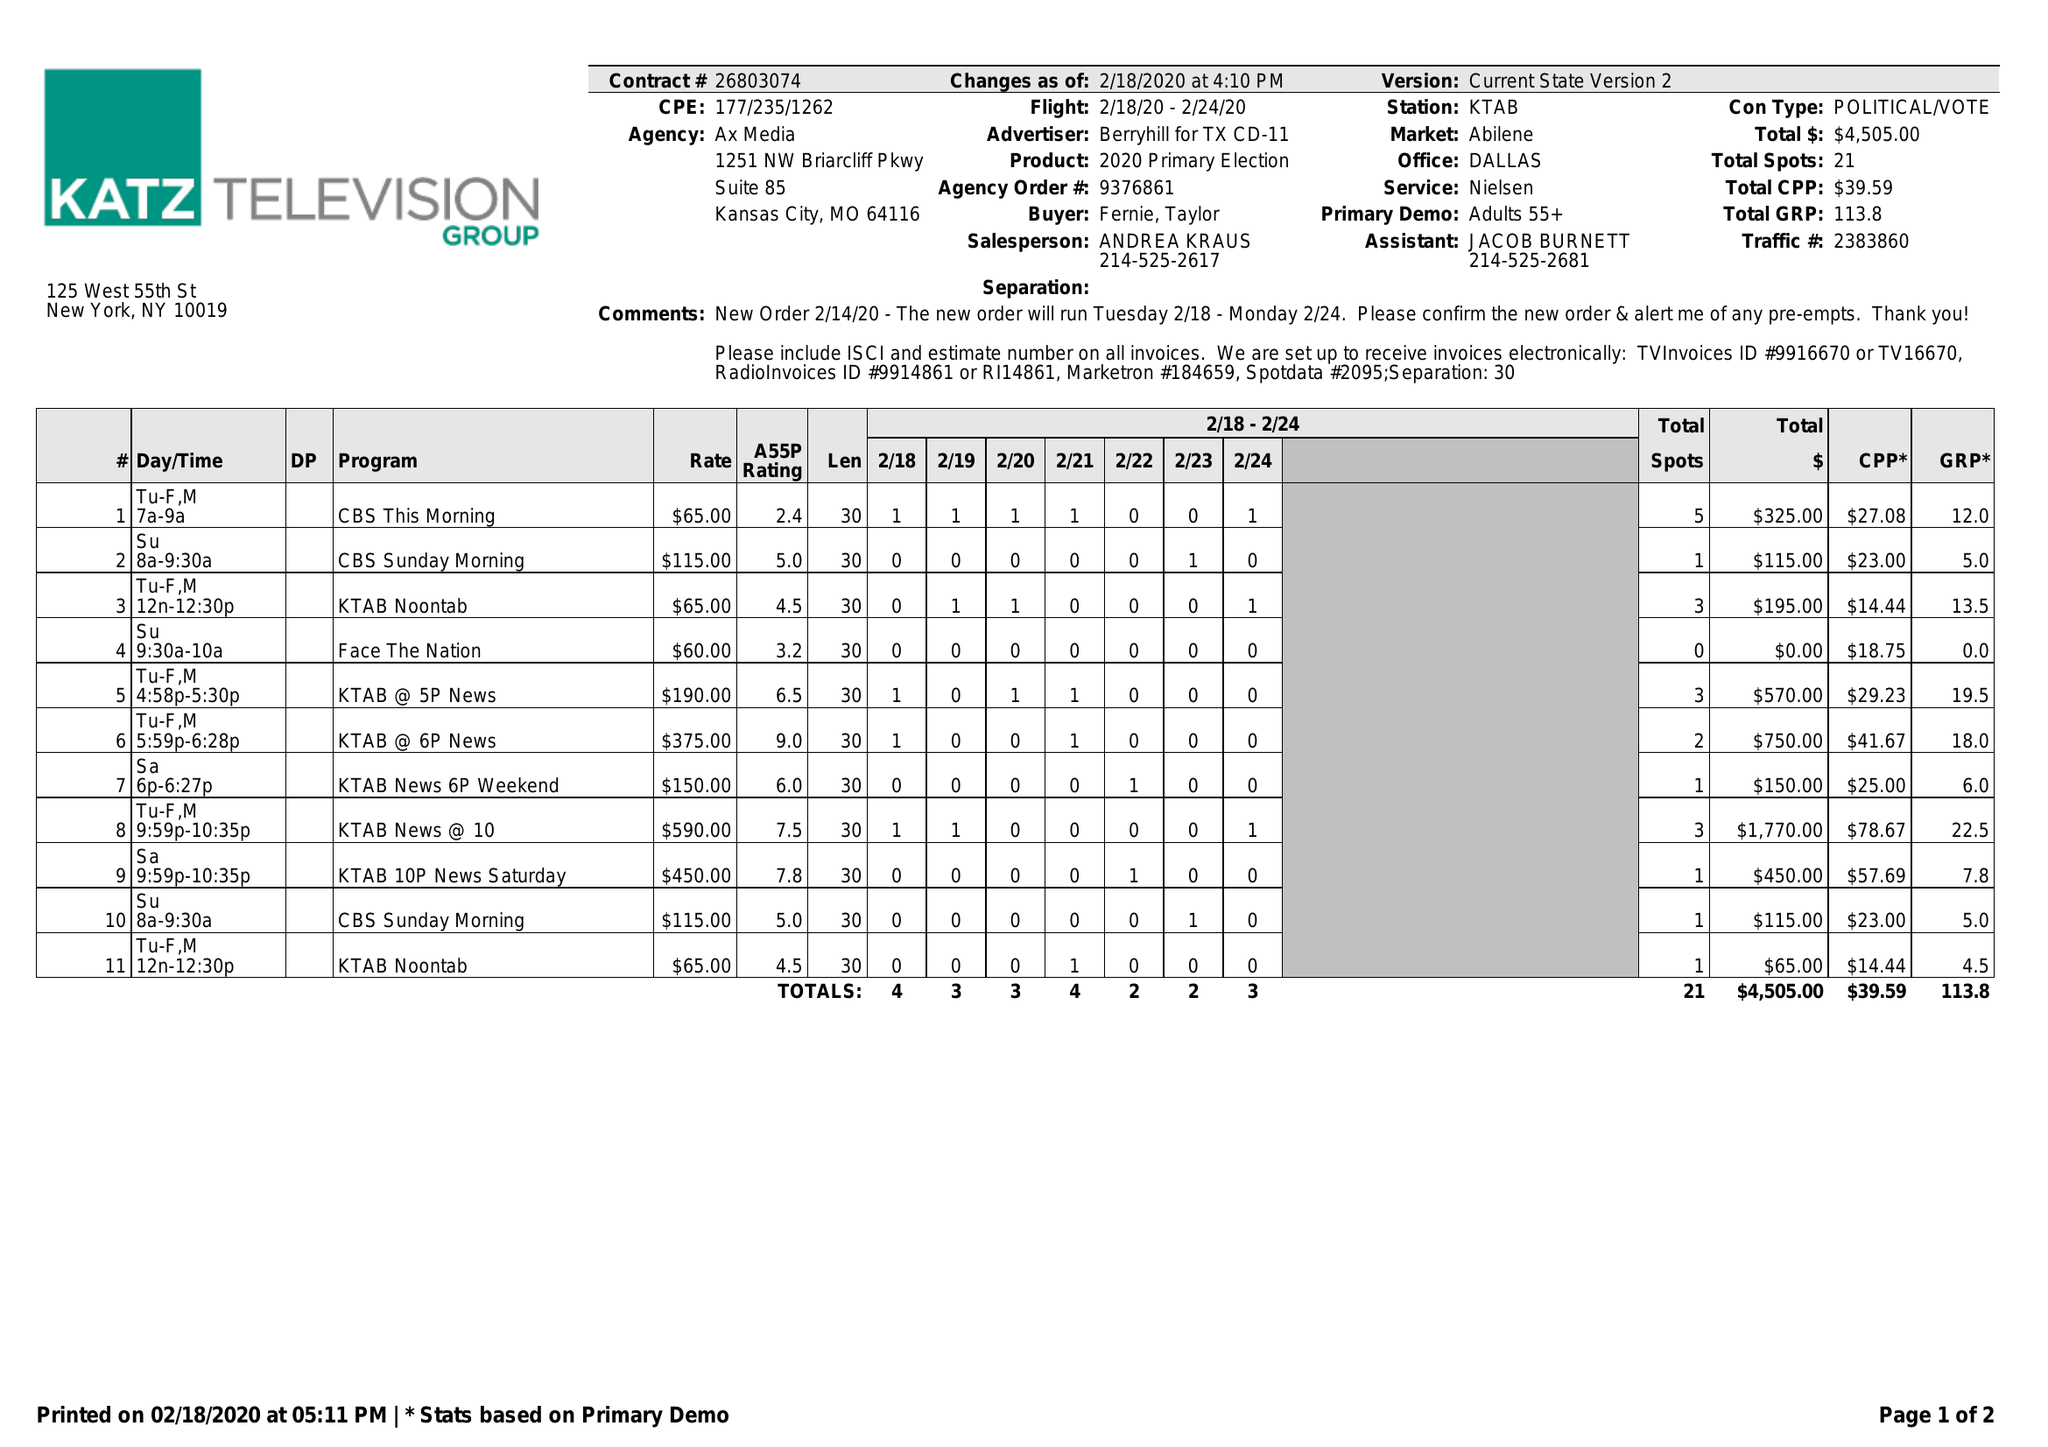What is the value for the contract_num?
Answer the question using a single word or phrase. 26803074 